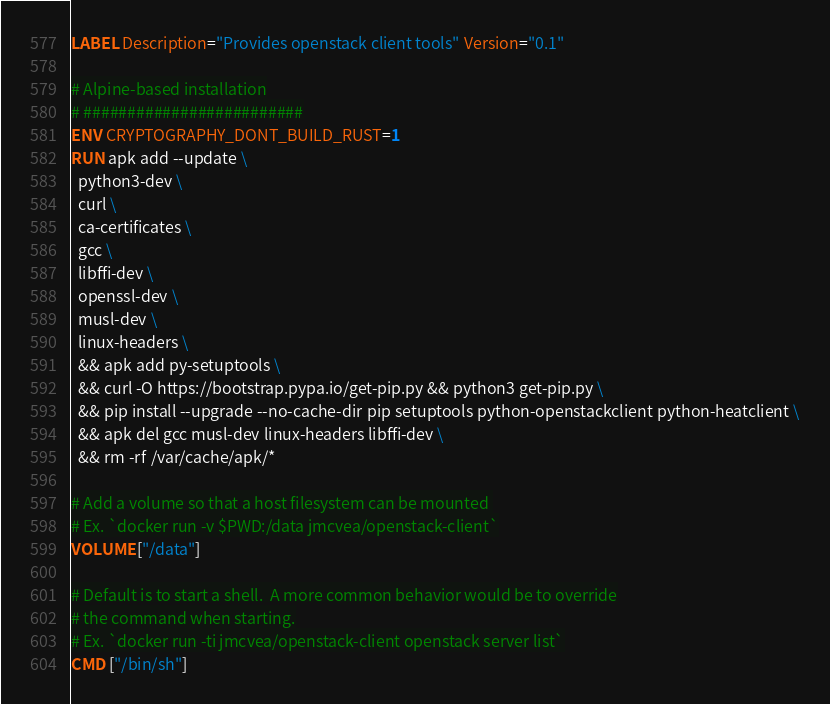Convert code to text. <code><loc_0><loc_0><loc_500><loc_500><_Dockerfile_>LABEL Description="Provides openstack client tools" Version="0.1"

# Alpine-based installation
# #########################
ENV CRYPTOGRAPHY_DONT_BUILD_RUST=1
RUN apk add --update \
  python3-dev \
  curl \
  ca-certificates \
  gcc \
  libffi-dev \
  openssl-dev \
  musl-dev \
  linux-headers \
  && apk add py-setuptools \
  && curl -O https://bootstrap.pypa.io/get-pip.py && python3 get-pip.py \
  && pip install --upgrade --no-cache-dir pip setuptools python-openstackclient python-heatclient \
  && apk del gcc musl-dev linux-headers libffi-dev \
  && rm -rf /var/cache/apk/*

# Add a volume so that a host filesystem can be mounted 
# Ex. `docker run -v $PWD:/data jmcvea/openstack-client`
VOLUME ["/data"]

# Default is to start a shell.  A more common behavior would be to override
# the command when starting.
# Ex. `docker run -ti jmcvea/openstack-client openstack server list`
CMD ["/bin/sh"]

</code> 